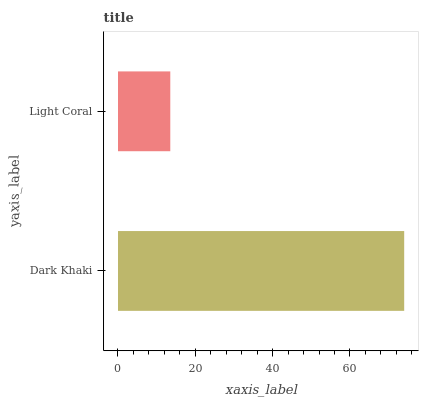Is Light Coral the minimum?
Answer yes or no. Yes. Is Dark Khaki the maximum?
Answer yes or no. Yes. Is Light Coral the maximum?
Answer yes or no. No. Is Dark Khaki greater than Light Coral?
Answer yes or no. Yes. Is Light Coral less than Dark Khaki?
Answer yes or no. Yes. Is Light Coral greater than Dark Khaki?
Answer yes or no. No. Is Dark Khaki less than Light Coral?
Answer yes or no. No. Is Dark Khaki the high median?
Answer yes or no. Yes. Is Light Coral the low median?
Answer yes or no. Yes. Is Light Coral the high median?
Answer yes or no. No. Is Dark Khaki the low median?
Answer yes or no. No. 